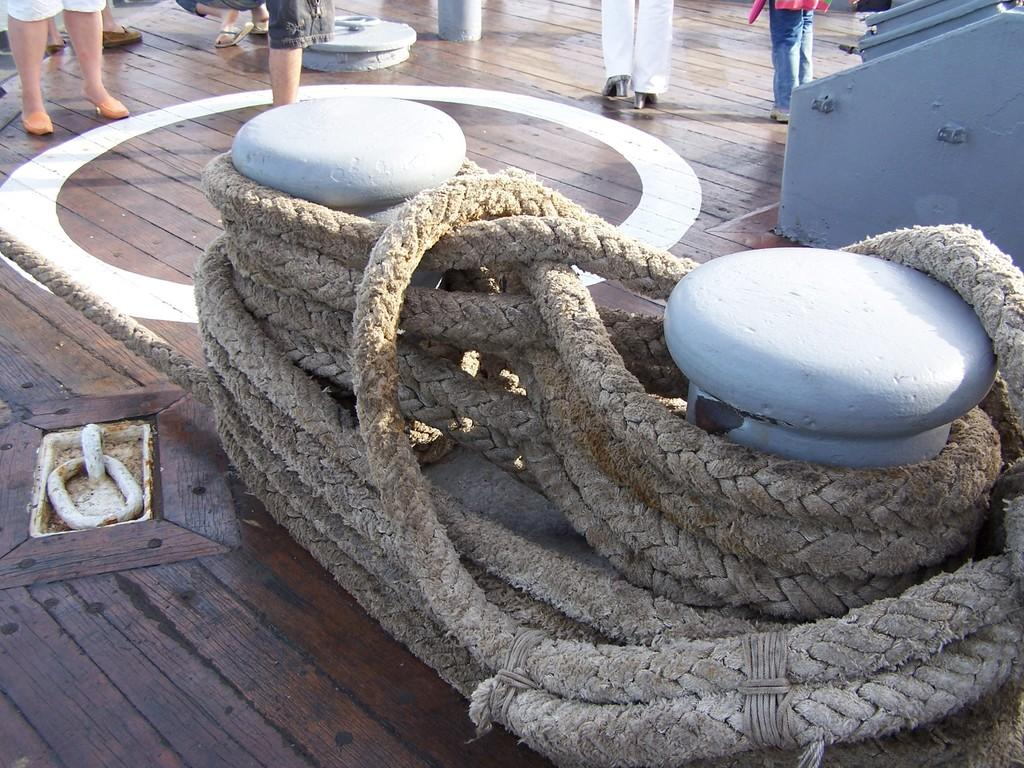What is on the wooden floor in the image? There is a rope on the wooden floor. Are there any people present in the image? Yes, there are people standing around the rope. What type of sofa can be seen in the image? There is no sofa present in the image. Is the rope being used to tie up a dock in the image? There is no dock present in the image, and the rope is not being used to tie anything. 